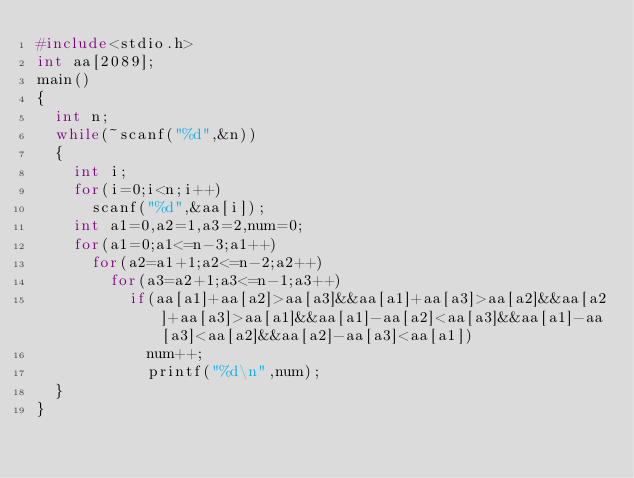<code> <loc_0><loc_0><loc_500><loc_500><_C++_>#include<stdio.h>
int aa[2089];
main()
{
	int n;
	while(~scanf("%d",&n))
	{
		int i;
		for(i=0;i<n;i++)
			scanf("%d",&aa[i]);
		int a1=0,a2=1,a3=2,num=0;
		for(a1=0;a1<=n-3;a1++)
			for(a2=a1+1;a2<=n-2;a2++)
				for(a3=a2+1;a3<=n-1;a3++)
					if(aa[a1]+aa[a2]>aa[a3]&&aa[a1]+aa[a3]>aa[a2]&&aa[a2]+aa[a3]>aa[a1]&&aa[a1]-aa[a2]<aa[a3]&&aa[a1]-aa[a3]<aa[a2]&&aa[a2]-aa[a3]<aa[a1])
						num++;
						printf("%d\n",num);
	}
}</code> 